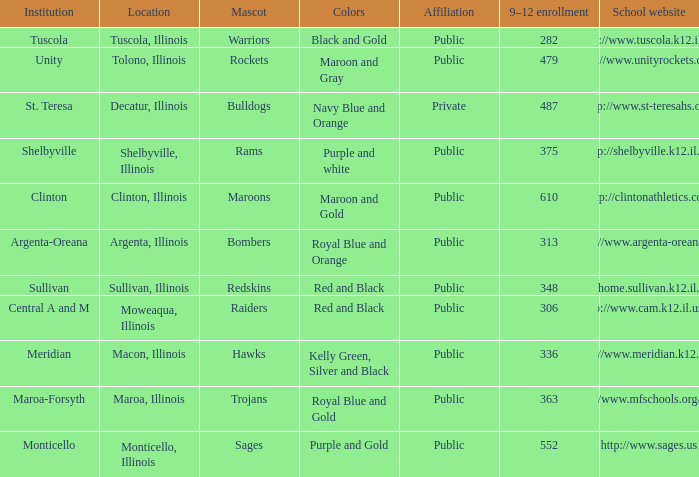What location has 363 students enrolled in the 9th to 12th grades? Maroa, Illinois. 